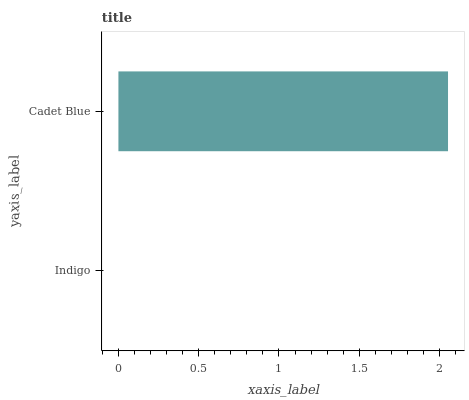Is Indigo the minimum?
Answer yes or no. Yes. Is Cadet Blue the maximum?
Answer yes or no. Yes. Is Cadet Blue the minimum?
Answer yes or no. No. Is Cadet Blue greater than Indigo?
Answer yes or no. Yes. Is Indigo less than Cadet Blue?
Answer yes or no. Yes. Is Indigo greater than Cadet Blue?
Answer yes or no. No. Is Cadet Blue less than Indigo?
Answer yes or no. No. Is Cadet Blue the high median?
Answer yes or no. Yes. Is Indigo the low median?
Answer yes or no. Yes. Is Indigo the high median?
Answer yes or no. No. Is Cadet Blue the low median?
Answer yes or no. No. 